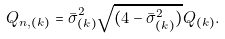Convert formula to latex. <formula><loc_0><loc_0><loc_500><loc_500>Q _ { n , ( k ) } = \bar { \sigma } _ { ( k ) } ^ { 2 } \sqrt { ( 4 - \bar { \sigma } _ { ( k ) } ^ { 2 } ) } Q _ { ( k ) } .</formula> 